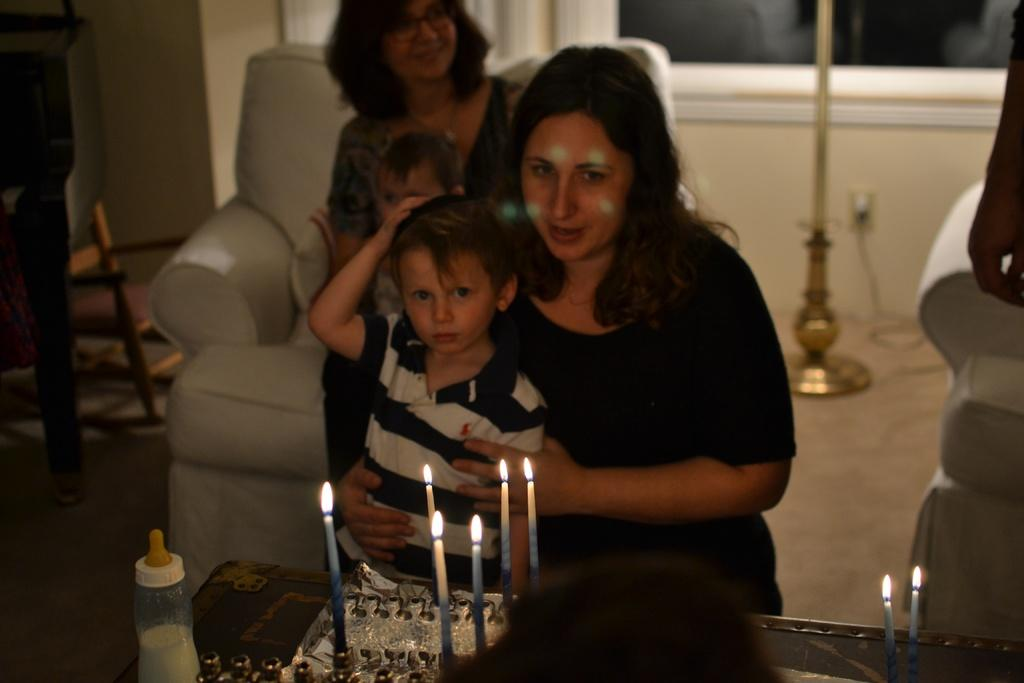Who or what is present in the image? There are people in the image. What is on the table in the image? There is a cake and candles on the table in the image. What is the bottle used for in the image? The bottle's purpose is not specified in the image, but it might be used for holding a beverage or other liquid. What type of furniture is present in the image? The table and chairs are present in the image. What can be seen in the background of the image? There is a wall, a stand, a cable, and a floor visible in the background of the image. What type of prose is being recited by the uncle at the playground in the image? There is no uncle or playground present in the image, and no prose is being recited. 